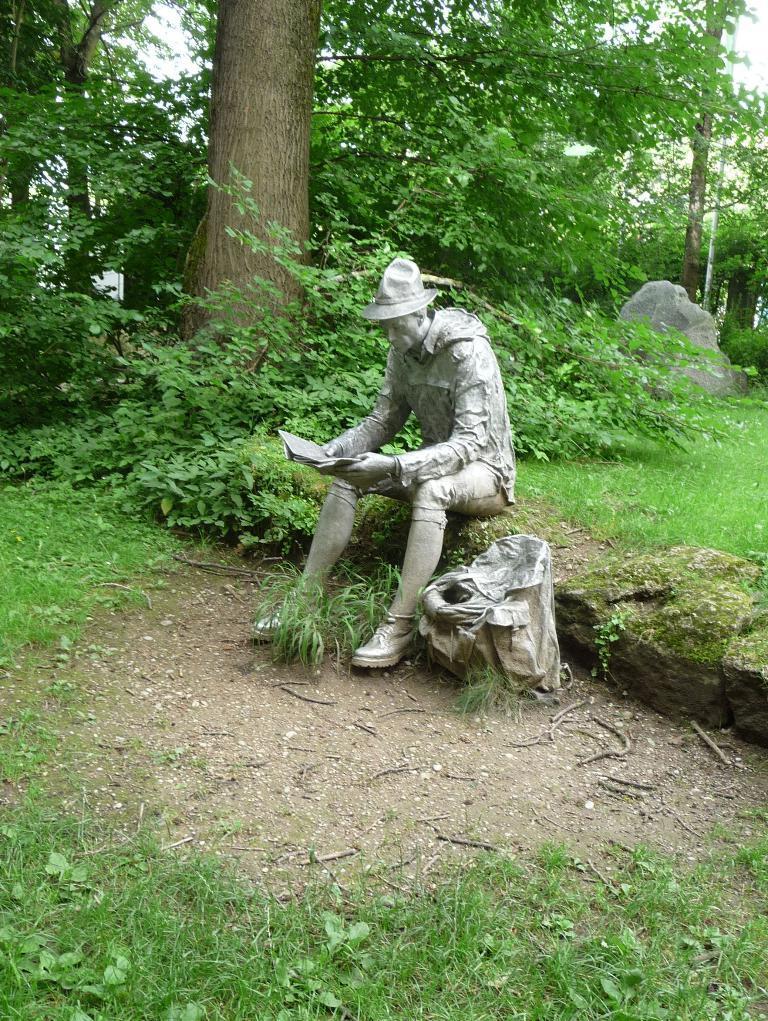Can you describe this image briefly? In this picture there is a statue of a person sitting and holding the book. At the back there are trees and there is a stone. At the top there is sky. At the bottom there is grass. 